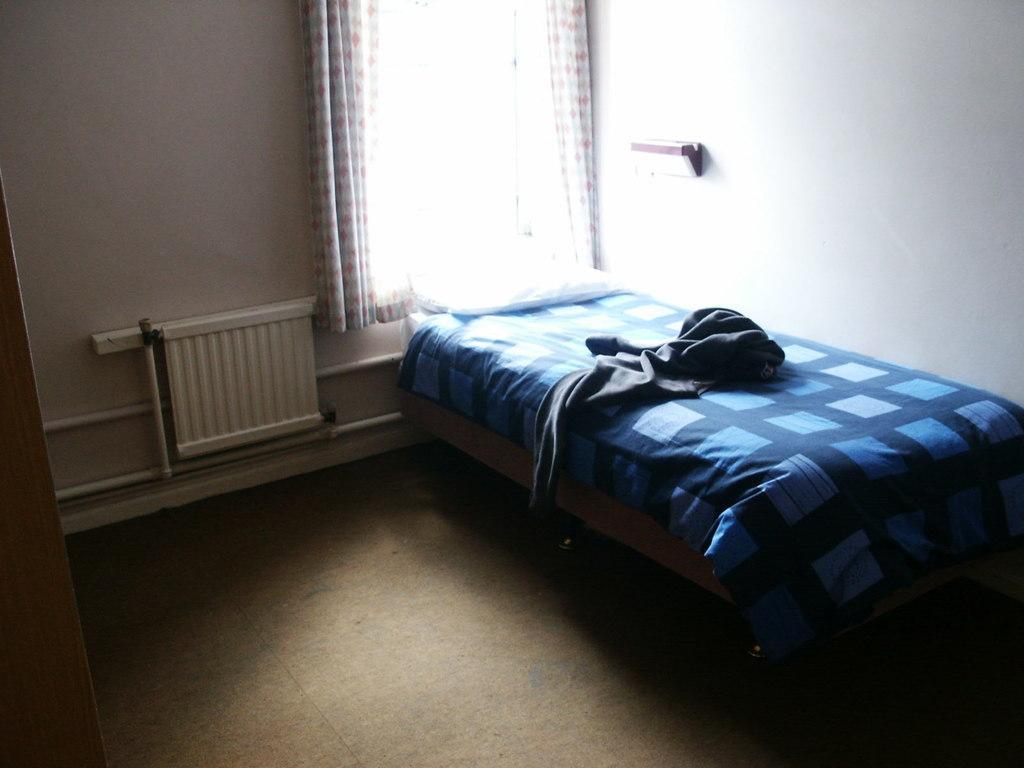How would you summarize this image in a sentence or two? In this image we see a cloth and a pillow on a bed. We can also see a wooden pole, a window with a curtain, a rack and a radiator on a wall. 